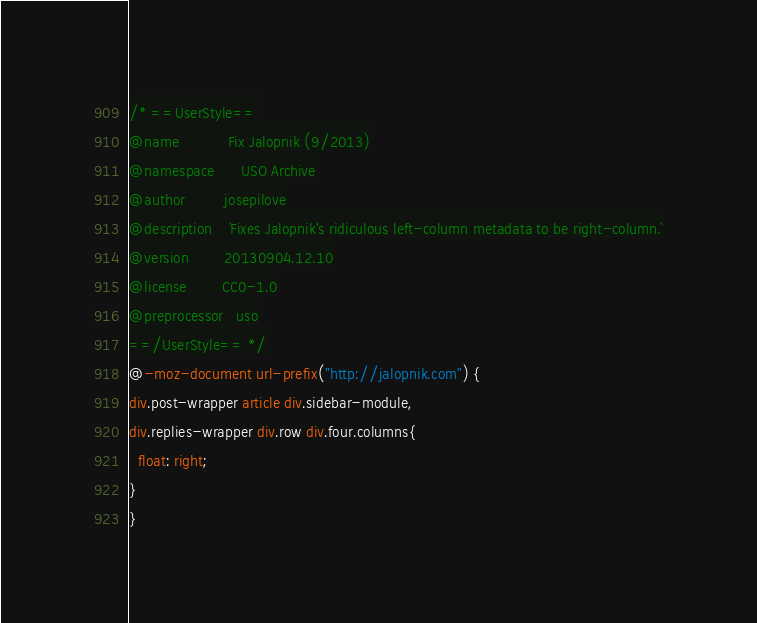Convert code to text. <code><loc_0><loc_0><loc_500><loc_500><_CSS_>/* ==UserStyle==
@name           Fix Jalopnik (9/2013)
@namespace      USO Archive
@author         josepilove
@description    `Fixes Jalopnik's ridiculous left-column metadata to be right-column.`
@version        20130904.12.10
@license        CC0-1.0
@preprocessor   uso
==/UserStyle== */
@-moz-document url-prefix("http://jalopnik.com") {
div.post-wrapper article div.sidebar-module,
div.replies-wrapper div.row div.four.columns{
  float: right;
}
}</code> 